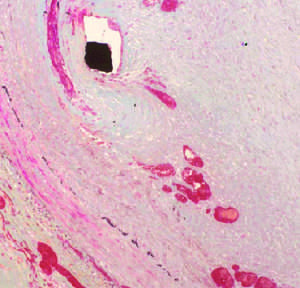does ischemic injury showing surface blebs show a thickened neointima overlying the stent wires black diamond encroaches on the lumen asterisk?
Answer the question using a single word or phrase. No 